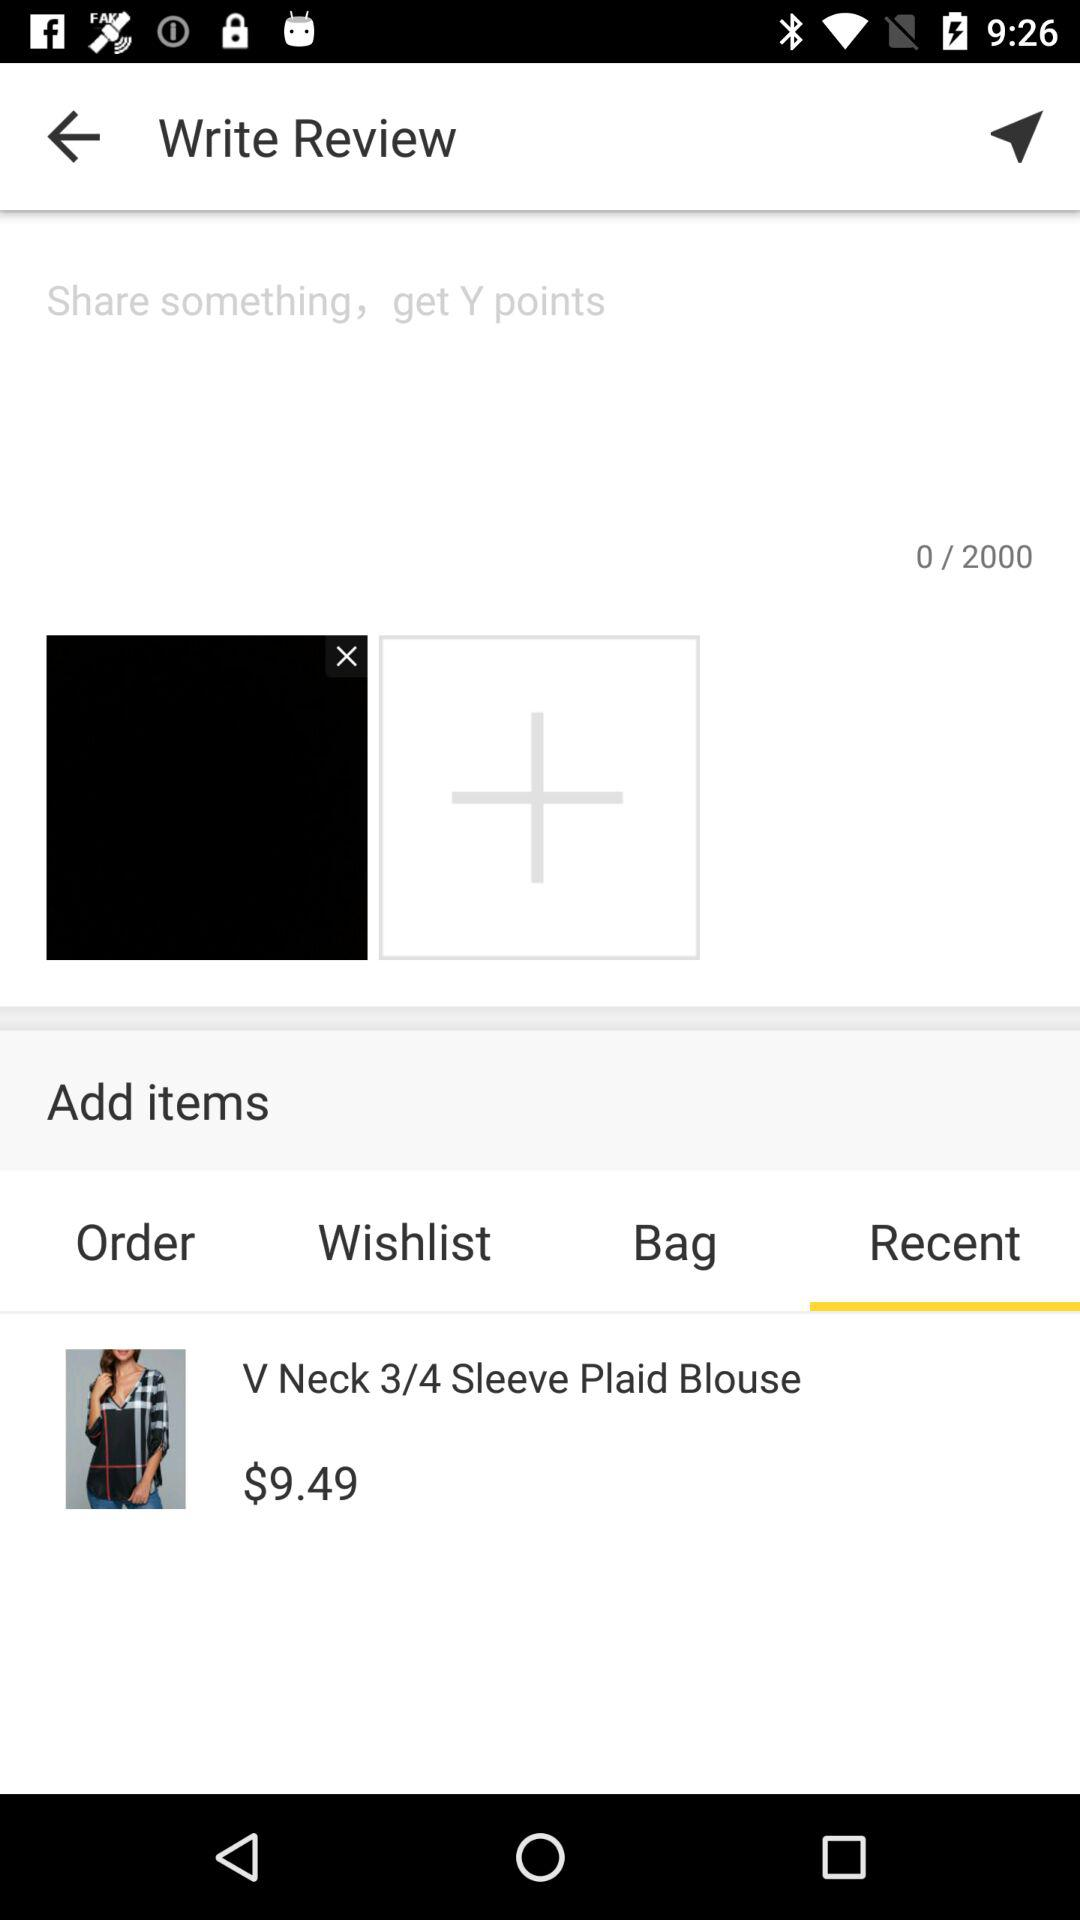What is the price of the "V Neck 3/4 Sleeve Plaid Blouse"? The price is $9.49. 